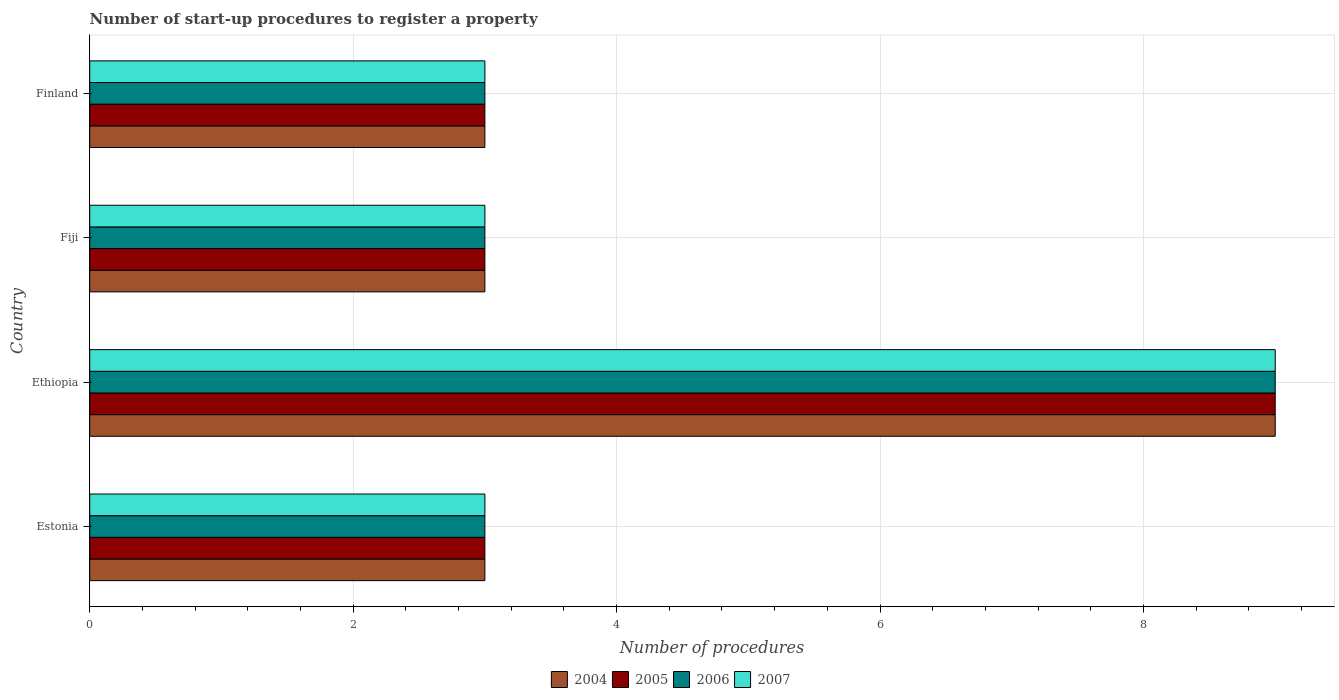How many groups of bars are there?
Your answer should be compact. 4. Are the number of bars per tick equal to the number of legend labels?
Ensure brevity in your answer.  Yes. How many bars are there on the 4th tick from the top?
Your answer should be very brief. 4. How many bars are there on the 4th tick from the bottom?
Keep it short and to the point. 4. What is the label of the 3rd group of bars from the top?
Make the answer very short. Ethiopia. What is the number of procedures required to register a property in 2006 in Fiji?
Keep it short and to the point. 3. In which country was the number of procedures required to register a property in 2005 maximum?
Offer a very short reply. Ethiopia. In which country was the number of procedures required to register a property in 2004 minimum?
Your response must be concise. Estonia. What is the difference between the number of procedures required to register a property in 2007 in Fiji and the number of procedures required to register a property in 2005 in Estonia?
Offer a terse response. 0. In how many countries, is the number of procedures required to register a property in 2007 greater than 6 ?
Provide a short and direct response. 1. What is the ratio of the number of procedures required to register a property in 2007 in Estonia to that in Ethiopia?
Ensure brevity in your answer.  0.33. Is the difference between the number of procedures required to register a property in 2004 in Estonia and Finland greater than the difference between the number of procedures required to register a property in 2007 in Estonia and Finland?
Provide a succinct answer. No. Is the sum of the number of procedures required to register a property in 2007 in Fiji and Finland greater than the maximum number of procedures required to register a property in 2004 across all countries?
Your answer should be very brief. No. Is it the case that in every country, the sum of the number of procedures required to register a property in 2007 and number of procedures required to register a property in 2004 is greater than the sum of number of procedures required to register a property in 2005 and number of procedures required to register a property in 2006?
Your answer should be compact. No. Is it the case that in every country, the sum of the number of procedures required to register a property in 2004 and number of procedures required to register a property in 2005 is greater than the number of procedures required to register a property in 2006?
Provide a short and direct response. Yes. Are all the bars in the graph horizontal?
Your answer should be very brief. Yes. What is the difference between two consecutive major ticks on the X-axis?
Provide a short and direct response. 2. Does the graph contain grids?
Provide a succinct answer. Yes. Where does the legend appear in the graph?
Ensure brevity in your answer.  Bottom center. How many legend labels are there?
Your response must be concise. 4. How are the legend labels stacked?
Make the answer very short. Horizontal. What is the title of the graph?
Provide a short and direct response. Number of start-up procedures to register a property. What is the label or title of the X-axis?
Provide a short and direct response. Number of procedures. What is the Number of procedures of 2004 in Estonia?
Your answer should be compact. 3. What is the Number of procedures of 2006 in Estonia?
Your response must be concise. 3. What is the Number of procedures in 2004 in Ethiopia?
Your response must be concise. 9. What is the Number of procedures of 2007 in Ethiopia?
Provide a succinct answer. 9. What is the Number of procedures in 2006 in Fiji?
Provide a short and direct response. 3. What is the Number of procedures in 2007 in Fiji?
Give a very brief answer. 3. What is the Number of procedures of 2006 in Finland?
Your response must be concise. 3. Across all countries, what is the maximum Number of procedures in 2005?
Give a very brief answer. 9. Across all countries, what is the maximum Number of procedures of 2006?
Your answer should be compact. 9. Across all countries, what is the minimum Number of procedures in 2006?
Your answer should be compact. 3. Across all countries, what is the minimum Number of procedures of 2007?
Offer a terse response. 3. What is the total Number of procedures in 2007 in the graph?
Your response must be concise. 18. What is the difference between the Number of procedures in 2007 in Estonia and that in Ethiopia?
Your answer should be very brief. -6. What is the difference between the Number of procedures in 2004 in Estonia and that in Fiji?
Keep it short and to the point. 0. What is the difference between the Number of procedures of 2005 in Estonia and that in Fiji?
Your response must be concise. 0. What is the difference between the Number of procedures in 2006 in Estonia and that in Fiji?
Provide a short and direct response. 0. What is the difference between the Number of procedures of 2007 in Estonia and that in Fiji?
Your answer should be compact. 0. What is the difference between the Number of procedures of 2005 in Estonia and that in Finland?
Give a very brief answer. 0. What is the difference between the Number of procedures of 2006 in Ethiopia and that in Fiji?
Ensure brevity in your answer.  6. What is the difference between the Number of procedures of 2007 in Ethiopia and that in Finland?
Your answer should be very brief. 6. What is the difference between the Number of procedures of 2005 in Fiji and that in Finland?
Keep it short and to the point. 0. What is the difference between the Number of procedures of 2004 in Estonia and the Number of procedures of 2005 in Ethiopia?
Keep it short and to the point. -6. What is the difference between the Number of procedures in 2004 in Estonia and the Number of procedures in 2006 in Ethiopia?
Ensure brevity in your answer.  -6. What is the difference between the Number of procedures of 2005 in Estonia and the Number of procedures of 2007 in Ethiopia?
Make the answer very short. -6. What is the difference between the Number of procedures in 2006 in Estonia and the Number of procedures in 2007 in Ethiopia?
Provide a succinct answer. -6. What is the difference between the Number of procedures of 2004 in Estonia and the Number of procedures of 2006 in Fiji?
Provide a succinct answer. 0. What is the difference between the Number of procedures in 2004 in Estonia and the Number of procedures in 2007 in Fiji?
Provide a succinct answer. 0. What is the difference between the Number of procedures in 2006 in Estonia and the Number of procedures in 2007 in Fiji?
Give a very brief answer. 0. What is the difference between the Number of procedures in 2004 in Estonia and the Number of procedures in 2007 in Finland?
Your answer should be very brief. 0. What is the difference between the Number of procedures of 2005 in Estonia and the Number of procedures of 2006 in Finland?
Provide a succinct answer. 0. What is the difference between the Number of procedures in 2005 in Estonia and the Number of procedures in 2007 in Finland?
Keep it short and to the point. 0. What is the difference between the Number of procedures of 2004 in Ethiopia and the Number of procedures of 2006 in Fiji?
Make the answer very short. 6. What is the difference between the Number of procedures of 2005 in Ethiopia and the Number of procedures of 2007 in Fiji?
Your answer should be compact. 6. What is the difference between the Number of procedures of 2004 in Ethiopia and the Number of procedures of 2005 in Finland?
Your answer should be very brief. 6. What is the difference between the Number of procedures in 2004 in Ethiopia and the Number of procedures in 2007 in Finland?
Make the answer very short. 6. What is the difference between the Number of procedures in 2005 in Ethiopia and the Number of procedures in 2006 in Finland?
Give a very brief answer. 6. What is the difference between the Number of procedures in 2004 in Fiji and the Number of procedures in 2005 in Finland?
Make the answer very short. 0. What is the difference between the Number of procedures in 2004 in Fiji and the Number of procedures in 2006 in Finland?
Offer a very short reply. 0. What is the difference between the Number of procedures in 2004 in Fiji and the Number of procedures in 2007 in Finland?
Offer a terse response. 0. What is the difference between the Number of procedures in 2005 in Fiji and the Number of procedures in 2007 in Finland?
Ensure brevity in your answer.  0. What is the average Number of procedures in 2004 per country?
Your answer should be compact. 4.5. What is the average Number of procedures of 2005 per country?
Your answer should be compact. 4.5. What is the average Number of procedures of 2006 per country?
Keep it short and to the point. 4.5. What is the difference between the Number of procedures of 2004 and Number of procedures of 2007 in Estonia?
Ensure brevity in your answer.  0. What is the difference between the Number of procedures of 2005 and Number of procedures of 2006 in Estonia?
Your response must be concise. 0. What is the difference between the Number of procedures of 2005 and Number of procedures of 2007 in Estonia?
Offer a very short reply. 0. What is the difference between the Number of procedures of 2006 and Number of procedures of 2007 in Estonia?
Offer a very short reply. 0. What is the difference between the Number of procedures in 2004 and Number of procedures in 2005 in Ethiopia?
Your answer should be very brief. 0. What is the difference between the Number of procedures of 2004 and Number of procedures of 2006 in Ethiopia?
Offer a terse response. 0. What is the difference between the Number of procedures of 2005 and Number of procedures of 2007 in Ethiopia?
Your response must be concise. 0. What is the difference between the Number of procedures in 2006 and Number of procedures in 2007 in Ethiopia?
Offer a terse response. 0. What is the difference between the Number of procedures of 2005 and Number of procedures of 2007 in Fiji?
Offer a very short reply. 0. What is the difference between the Number of procedures of 2006 and Number of procedures of 2007 in Fiji?
Give a very brief answer. 0. What is the difference between the Number of procedures of 2004 and Number of procedures of 2005 in Finland?
Ensure brevity in your answer.  0. What is the difference between the Number of procedures of 2004 and Number of procedures of 2007 in Finland?
Your answer should be very brief. 0. What is the difference between the Number of procedures of 2005 and Number of procedures of 2007 in Finland?
Provide a succinct answer. 0. What is the ratio of the Number of procedures of 2004 in Estonia to that in Ethiopia?
Give a very brief answer. 0.33. What is the ratio of the Number of procedures of 2006 in Estonia to that in Ethiopia?
Give a very brief answer. 0.33. What is the ratio of the Number of procedures of 2007 in Estonia to that in Ethiopia?
Give a very brief answer. 0.33. What is the ratio of the Number of procedures in 2004 in Estonia to that in Fiji?
Make the answer very short. 1. What is the ratio of the Number of procedures of 2007 in Estonia to that in Fiji?
Provide a succinct answer. 1. What is the ratio of the Number of procedures of 2005 in Estonia to that in Finland?
Keep it short and to the point. 1. What is the ratio of the Number of procedures in 2007 in Estonia to that in Finland?
Keep it short and to the point. 1. What is the ratio of the Number of procedures in 2007 in Ethiopia to that in Fiji?
Ensure brevity in your answer.  3. What is the ratio of the Number of procedures of 2004 in Ethiopia to that in Finland?
Provide a succinct answer. 3. What is the ratio of the Number of procedures of 2004 in Fiji to that in Finland?
Provide a succinct answer. 1. What is the ratio of the Number of procedures of 2005 in Fiji to that in Finland?
Make the answer very short. 1. What is the ratio of the Number of procedures of 2007 in Fiji to that in Finland?
Provide a succinct answer. 1. What is the difference between the highest and the second highest Number of procedures in 2005?
Provide a short and direct response. 6. What is the difference between the highest and the second highest Number of procedures in 2006?
Ensure brevity in your answer.  6. What is the difference between the highest and the second highest Number of procedures of 2007?
Your response must be concise. 6. 